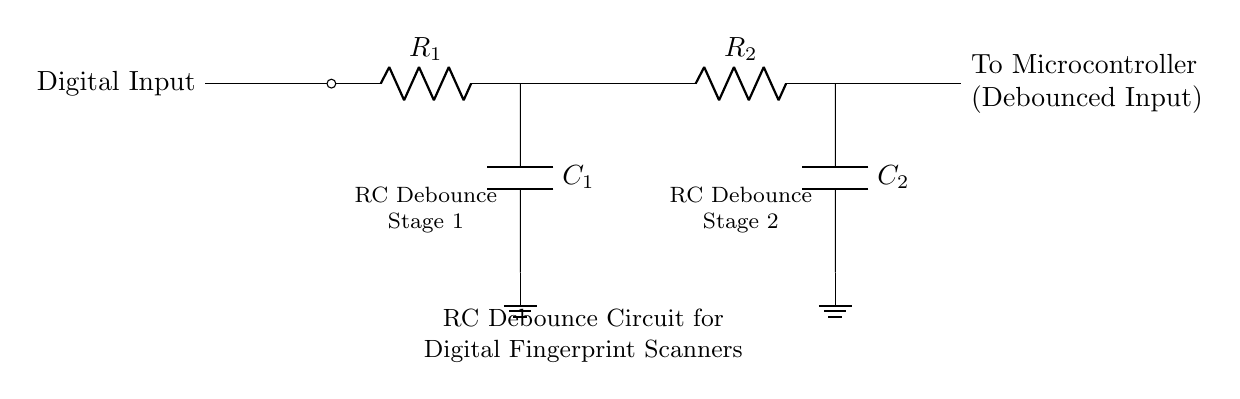What is the first component labeled in the circuit? The first component labeled in the circuit is a resistor, indicated as R1. It is the first element that follows the "Digital Input" in the diagram.
Answer: R1 How many capacitors are present in the circuit? The circuit contains two capacitors, labeled C1 and C2, which are positioned in the two debounce stages of the circuit.
Answer: 2 What does the circuit primarily function as? The circuit is primarily designed to debounce a digital signal, which means it filters out noise or spurious signals from the fingerprint scanner before sending a clean signal to the microcontroller.
Answer: Debounce What are the stages labeled in the circuit diagram? The stages labeled in the circuit are "RC Debounce Stage 1" and "RC Debounce Stage 2," indicating that there are two sequential filtering stages in the circuit.
Answer: Two stages Explain the purpose of the resistors in the circuit. The resistors in the circuit (R1 and R2) are part of the RC debounce mechanism. They control the timing of voltage changes across the capacitors, allowing for a smooth transition to the microcontroller during finger detection. Without these resistors, rapid fluctuations could cause false triggers.
Answer: Timing control What is the role of the capacitor labeled C1? Capacitor C1's role is to charge and discharge based on the input signal, helping to smooth out any transient signals that could cause multiple quick signals from the fingerprint scanner before it stabilizes. This process ensures that only one valid signal is passed to the microcontroller.
Answer: Smoothing signals Which connection leads to the microcontroller? The connection that leads to the microcontroller is from the second resistor R2, tapping off the output of the second capacitor C2, sending a debounced signal to the microcontroller for processing.
Answer: To microcontroller 